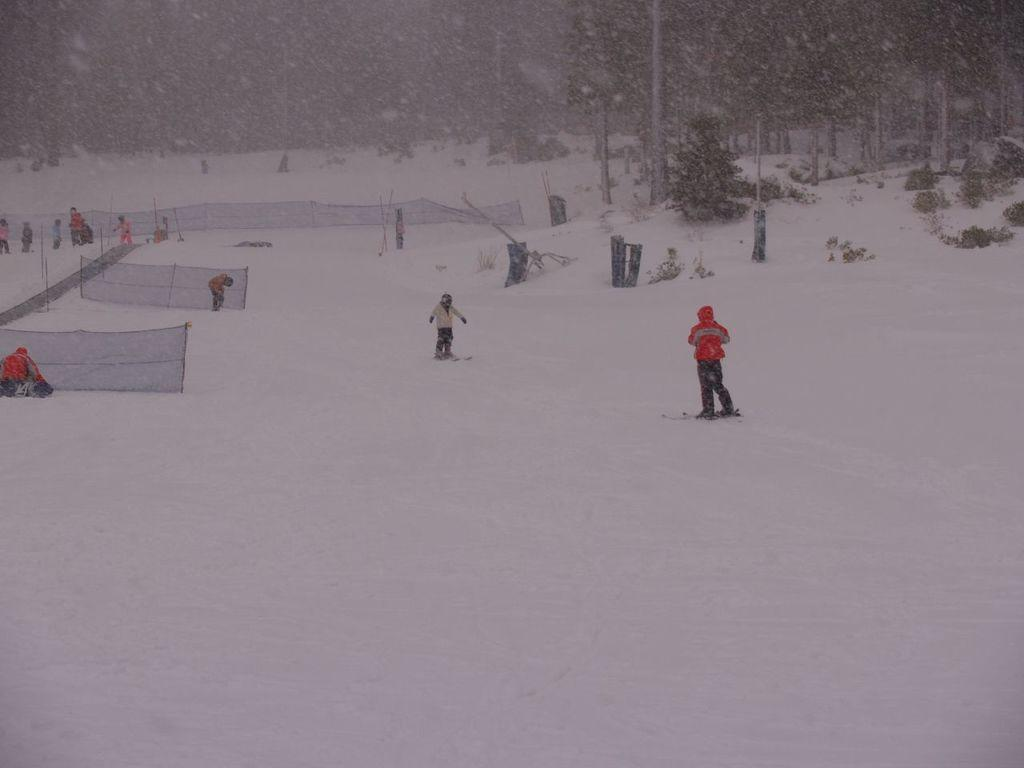Who or what is present in the image? There are people in the image. What is the environment like in the image? The people are in snow. What can be seen in the background of the image? There are nets, poles, and trees in the background of the image. How does the seed get washed in the image? There is no seed present in the image, so it cannot be washed. 